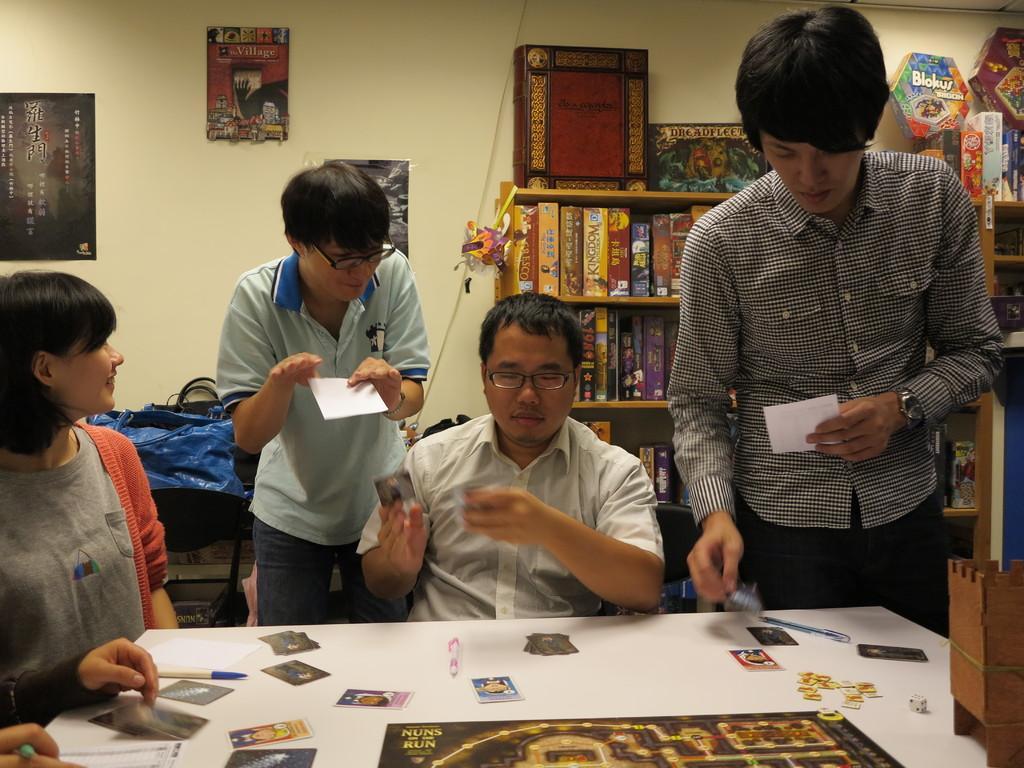Please provide a concise description of this image. In this image I see 3 men and a woman and I see that there are cards, a dice, 2 pens and a board over here and I see that this woman is smiling. In the background I see the books on the racks and I see 3 posts on the wall and I see the blue bag over here. I can also see few more things over here. 